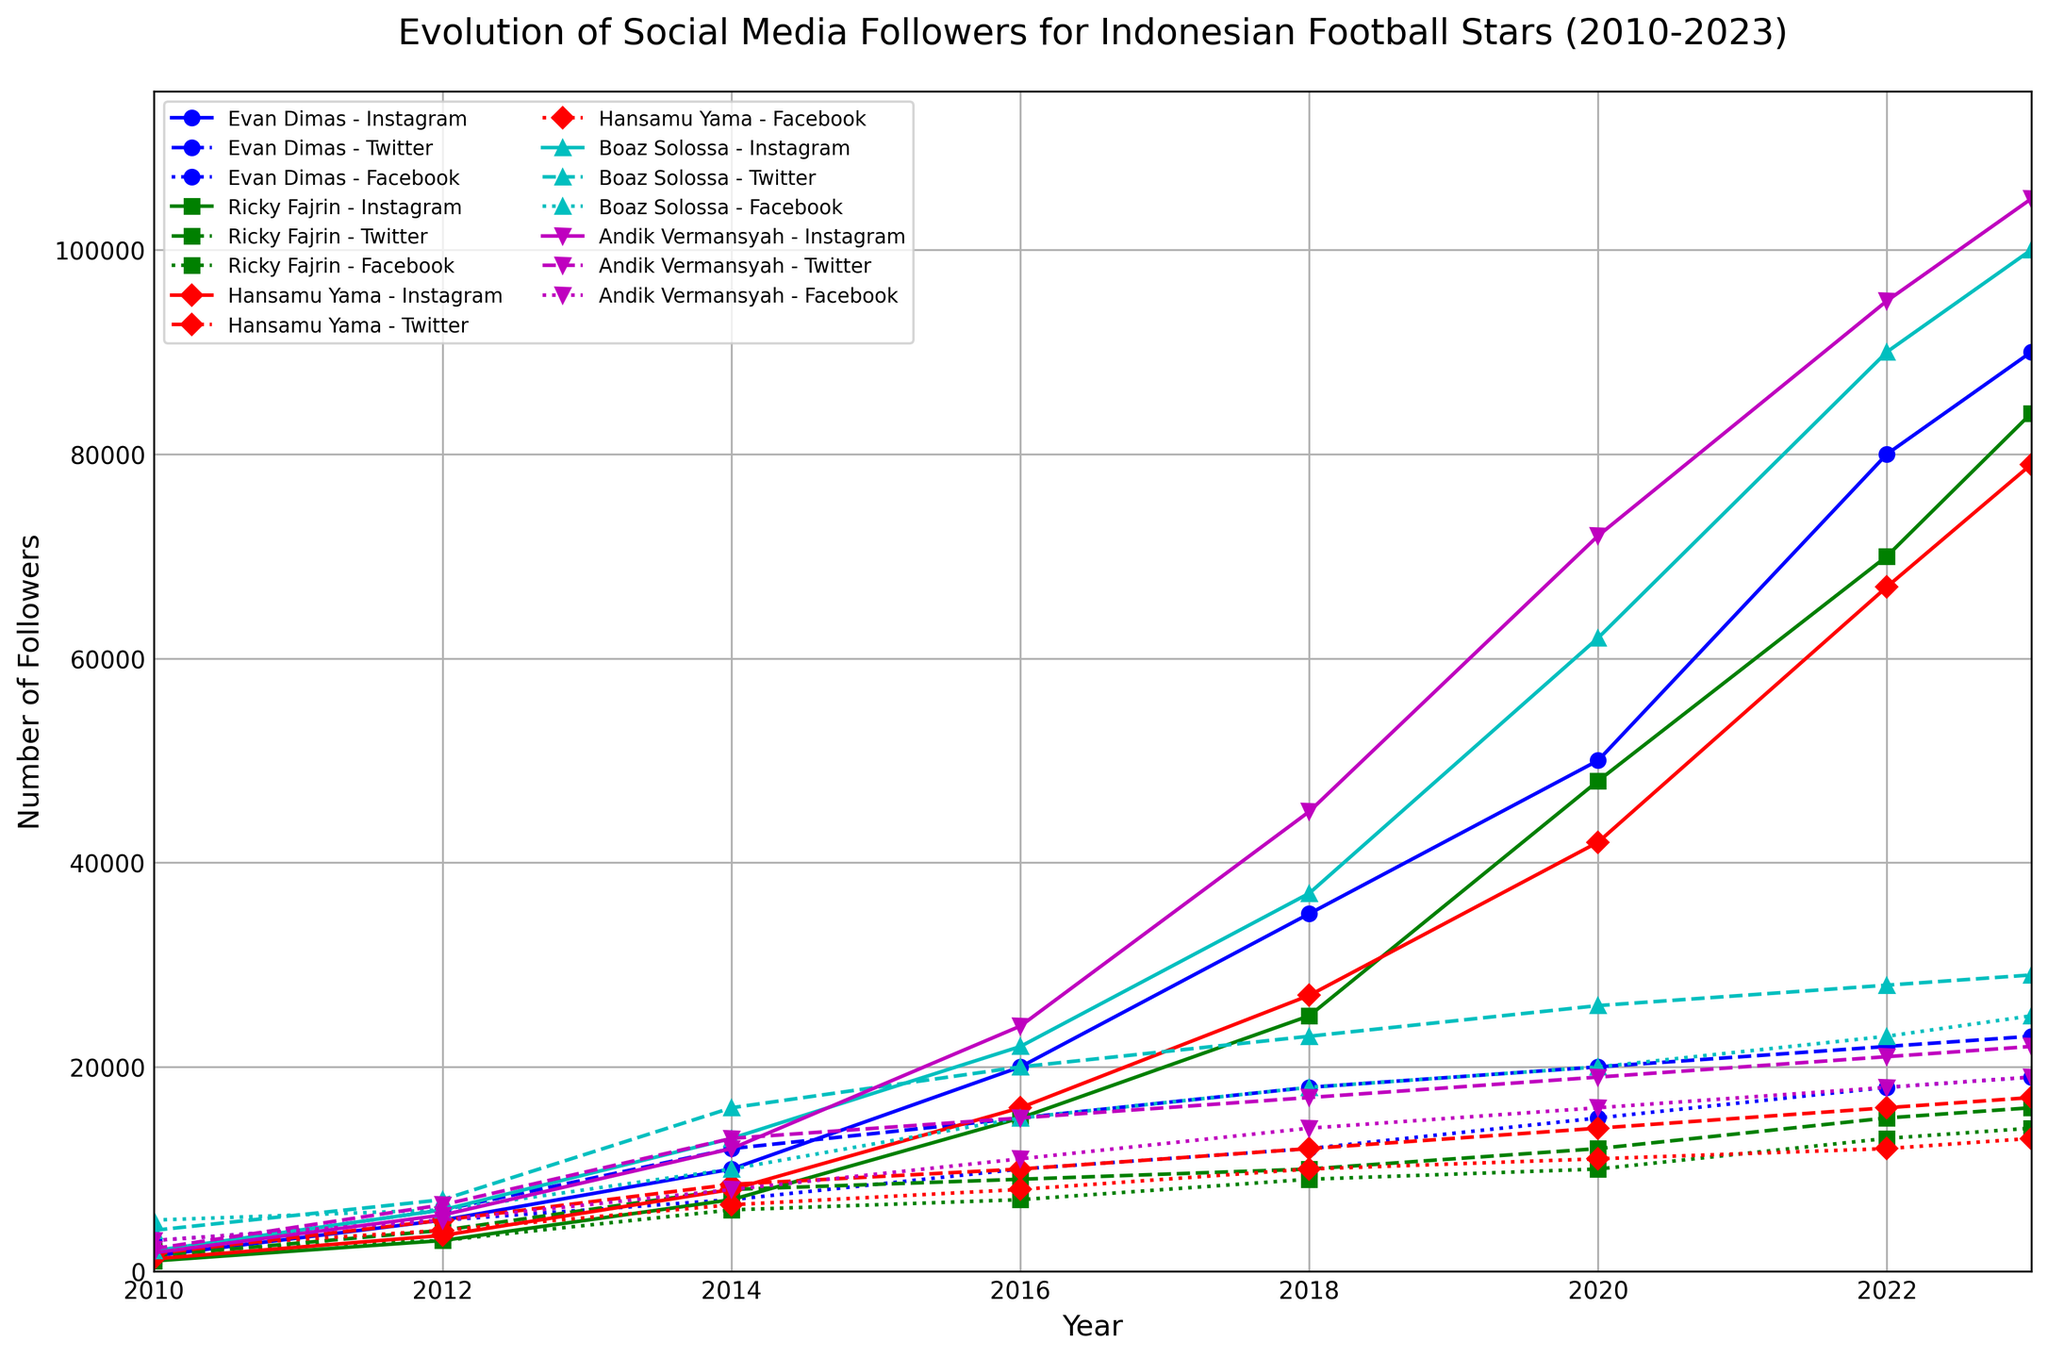Which Indonesian football star had the highest number of Instagram followers in 2023? Look at the line representing Instagram followers for each football star in 2023. The highest point corresponds to Andik Vermansyah with 105,000 followers.
Answer: Andik Vermansyah Between Evan Dimas and Boaz Solossa, who saw a more significant increase in Instagram followers from 2018 to 2023? Refer to the Instagram followers' data for both players in 2018 and 2023. Calculate the difference: Evan Dimas (90,000 - 35,000 = 55,000) and Boaz Solossa (100,000 - 37,000 = 63,000). Boaz Solossa saw a more significant increase.
Answer: Boaz Solossa Which football star had the least number of Twitter followers in 2016? Look at the lines representing Twitter followers in 2016 for all football stars. Ricky Fajrin had the least with 9,000 followers.
Answer: Ricky Fajrin How did the Facebook followers of Andik Vermansyah change from 2010 to 2023? Examine the data points for Andik Vermansyah's Facebook followers in 2010 and 2023. In 2010, he had 3,000 followers, and in 2023, he had 19,000 followers. The change is 16,000.
Answer: Increased by 16,000 Which player had the most consistent growth in Instagram followers from 2010 to 2023? Look at the trend lines of Instagram followers for all players over the observed period. Ricky Fajrin illustrates the most consistent, gradual increase without any sudden jumps.
Answer: Ricky Fajrin Compare the Instagram followers' growth of Hansamu Yama and Boaz Solossa between 2012 and 2016. Who had a higher percentage increase? Calculate the percentage increase for Hansamu Yama (16,000 - 3,500) / 3,500 * 100 = 357.14% and for Boaz Solossa (22,000 - 6,000) / 6,000 * 100 = 266.67%. Hansamu Yama had a higher percentage increase.
Answer: Hansamu Yama What is the average number of Instagram followers for all players in 2023? Sum the Instagram followers for all players in 2023 and divide by the number of players: (90,000 + 84,000 + 79,000 + 100,000 + 105,000) / 5 = 91,600.
Answer: 91,600 followers Which player experienced the sharpest decline in Twitter followers from 2014 to 2016? Compare the lines denoting Twitter followers from 2014 to 2016 for each player. Evan Dimas's followers dropped from 12,000 to 15,000 (decrease of 3,000). This is the smallest decrease observed among the players.
Answer: Evan Dimas How does the increase in Facebook followers of Boaz Solossa compare from 2010 to 2012 with Evan Dimas over the same period? Calculate the increase for both players. Boaz Solossa's Facebook followers increased from 5,000 to 6,000 (1,000 followers), Evan Dimas increased from 3,000 to 5,000 (2,000 followers). Evan Dimas had the higher increase.
Answer: Evan Dimas 